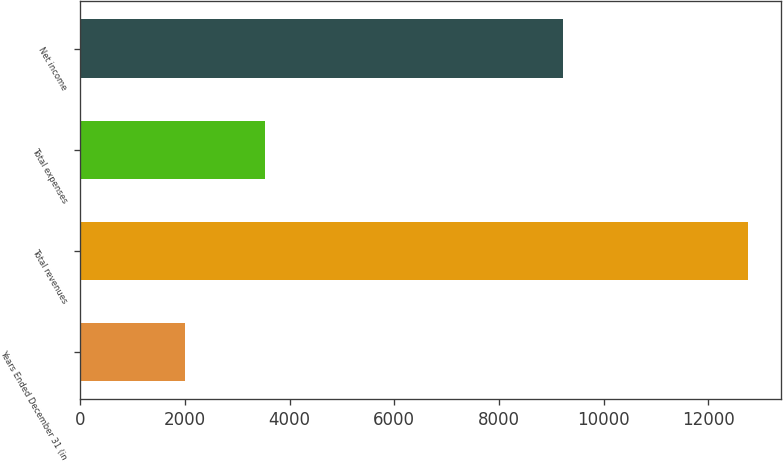Convert chart to OTSL. <chart><loc_0><loc_0><loc_500><loc_500><bar_chart><fcel>Years Ended December 31 (in<fcel>Total revenues<fcel>Total expenses<fcel>Net income<nl><fcel>2011<fcel>12749<fcel>3530<fcel>9219<nl></chart> 